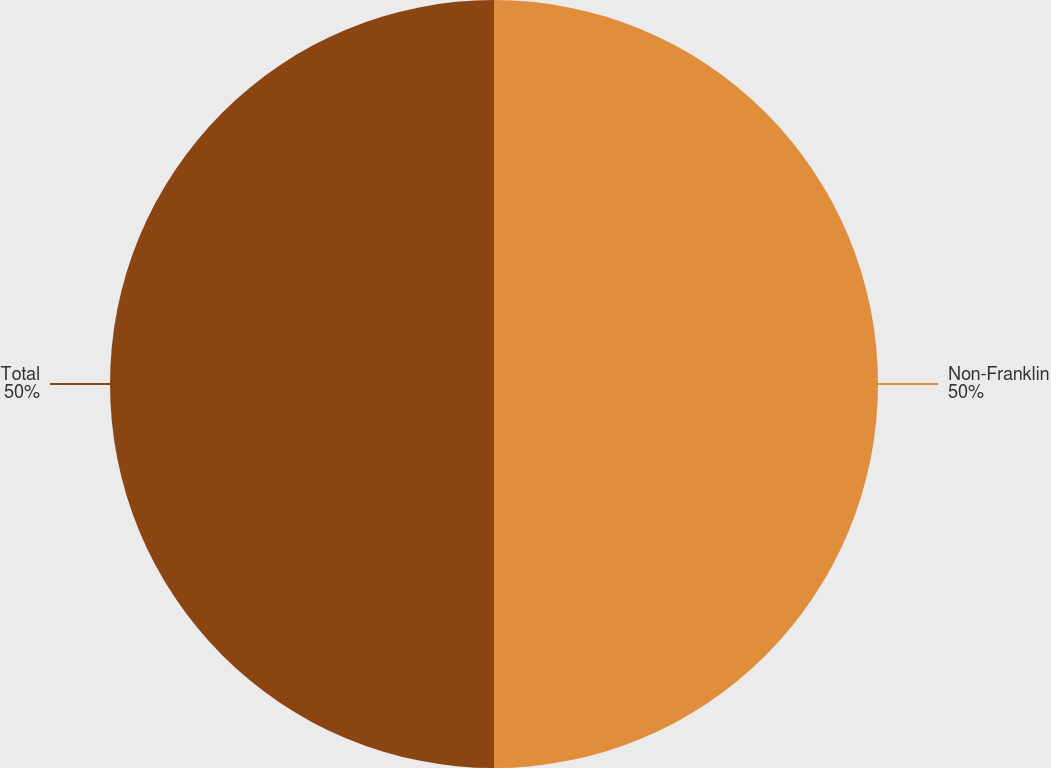Convert chart to OTSL. <chart><loc_0><loc_0><loc_500><loc_500><pie_chart><fcel>Non-Franklin<fcel>Total<nl><fcel>50.0%<fcel>50.0%<nl></chart> 